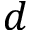Convert formula to latex. <formula><loc_0><loc_0><loc_500><loc_500>d</formula> 